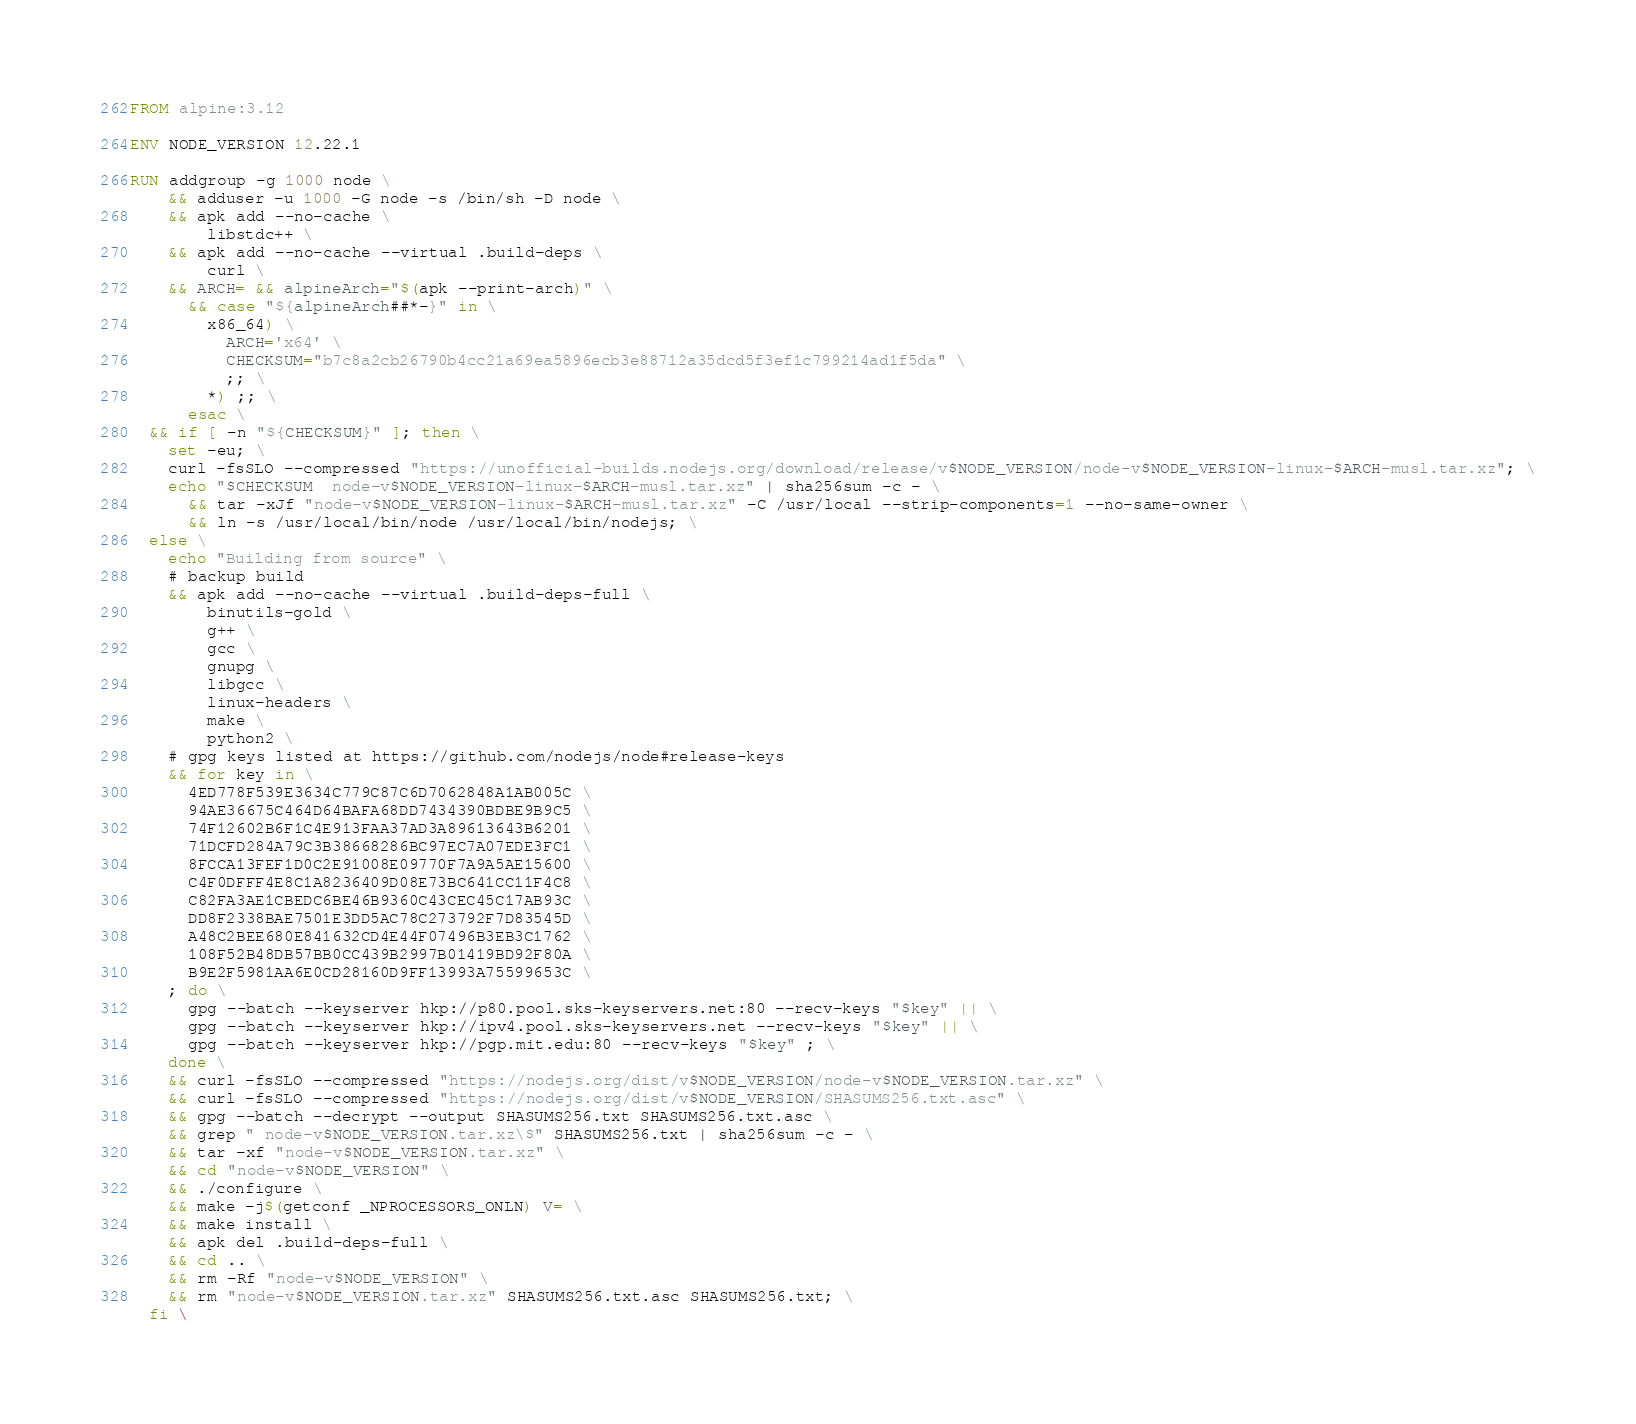Convert code to text. <code><loc_0><loc_0><loc_500><loc_500><_Dockerfile_>FROM alpine:3.12

ENV NODE_VERSION 12.22.1

RUN addgroup -g 1000 node \
    && adduser -u 1000 -G node -s /bin/sh -D node \
    && apk add --no-cache \
        libstdc++ \
    && apk add --no-cache --virtual .build-deps \
        curl \
    && ARCH= && alpineArch="$(apk --print-arch)" \
      && case "${alpineArch##*-}" in \
        x86_64) \
          ARCH='x64' \
          CHECKSUM="b7c8a2cb26790b4cc21a69ea5896ecb3e88712a35dcd5f3ef1c799214ad1f5da" \
          ;; \
        *) ;; \
      esac \
  && if [ -n "${CHECKSUM}" ]; then \
    set -eu; \
    curl -fsSLO --compressed "https://unofficial-builds.nodejs.org/download/release/v$NODE_VERSION/node-v$NODE_VERSION-linux-$ARCH-musl.tar.xz"; \
    echo "$CHECKSUM  node-v$NODE_VERSION-linux-$ARCH-musl.tar.xz" | sha256sum -c - \
      && tar -xJf "node-v$NODE_VERSION-linux-$ARCH-musl.tar.xz" -C /usr/local --strip-components=1 --no-same-owner \
      && ln -s /usr/local/bin/node /usr/local/bin/nodejs; \
  else \
    echo "Building from source" \
    # backup build
    && apk add --no-cache --virtual .build-deps-full \
        binutils-gold \
        g++ \
        gcc \
        gnupg \
        libgcc \
        linux-headers \
        make \
        python2 \
    # gpg keys listed at https://github.com/nodejs/node#release-keys
    && for key in \
      4ED778F539E3634C779C87C6D7062848A1AB005C \
      94AE36675C464D64BAFA68DD7434390BDBE9B9C5 \
      74F12602B6F1C4E913FAA37AD3A89613643B6201 \
      71DCFD284A79C3B38668286BC97EC7A07EDE3FC1 \
      8FCCA13FEF1D0C2E91008E09770F7A9A5AE15600 \
      C4F0DFFF4E8C1A8236409D08E73BC641CC11F4C8 \
      C82FA3AE1CBEDC6BE46B9360C43CEC45C17AB93C \
      DD8F2338BAE7501E3DD5AC78C273792F7D83545D \
      A48C2BEE680E841632CD4E44F07496B3EB3C1762 \
      108F52B48DB57BB0CC439B2997B01419BD92F80A \
      B9E2F5981AA6E0CD28160D9FF13993A75599653C \
    ; do \
      gpg --batch --keyserver hkp://p80.pool.sks-keyservers.net:80 --recv-keys "$key" || \
      gpg --batch --keyserver hkp://ipv4.pool.sks-keyservers.net --recv-keys "$key" || \
      gpg --batch --keyserver hkp://pgp.mit.edu:80 --recv-keys "$key" ; \
    done \
    && curl -fsSLO --compressed "https://nodejs.org/dist/v$NODE_VERSION/node-v$NODE_VERSION.tar.xz" \
    && curl -fsSLO --compressed "https://nodejs.org/dist/v$NODE_VERSION/SHASUMS256.txt.asc" \
    && gpg --batch --decrypt --output SHASUMS256.txt SHASUMS256.txt.asc \
    && grep " node-v$NODE_VERSION.tar.xz\$" SHASUMS256.txt | sha256sum -c - \
    && tar -xf "node-v$NODE_VERSION.tar.xz" \
    && cd "node-v$NODE_VERSION" \
    && ./configure \
    && make -j$(getconf _NPROCESSORS_ONLN) V= \
    && make install \
    && apk del .build-deps-full \
    && cd .. \
    && rm -Rf "node-v$NODE_VERSION" \
    && rm "node-v$NODE_VERSION.tar.xz" SHASUMS256.txt.asc SHASUMS256.txt; \
  fi \</code> 